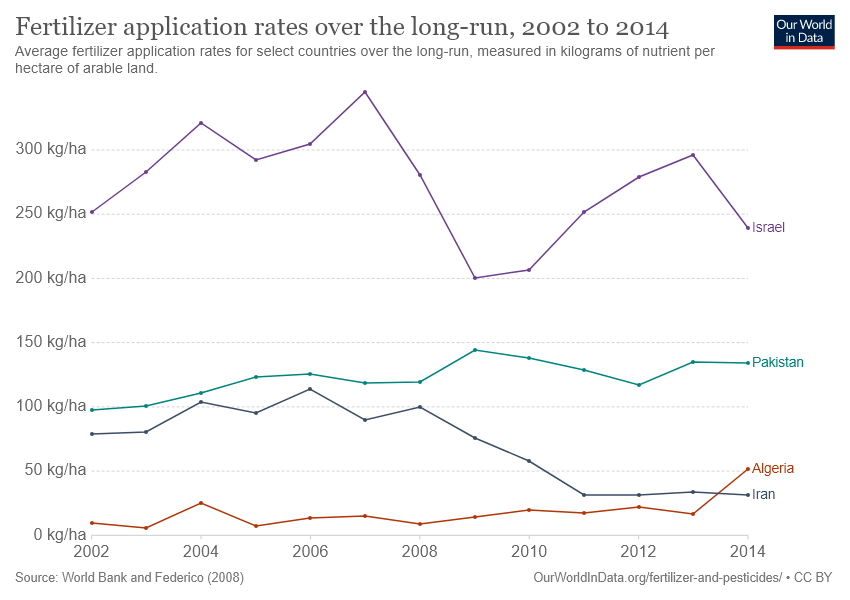Indicate a few pertinent items in this graphic. The application rates of Pakistan and Iran have been compared and it has been found that Pakistan has a higher application rate over the years. The application rates in Israel were maximum between the years 2006 and 2008. 